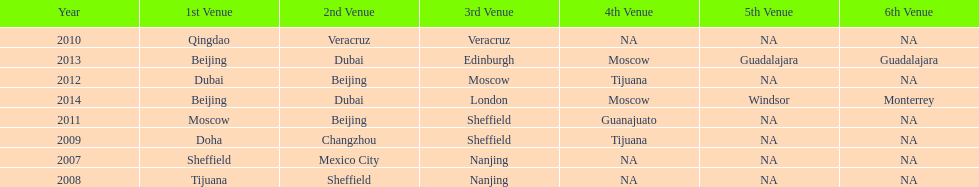Name a year whose second venue was the same as 2011. 2012. 